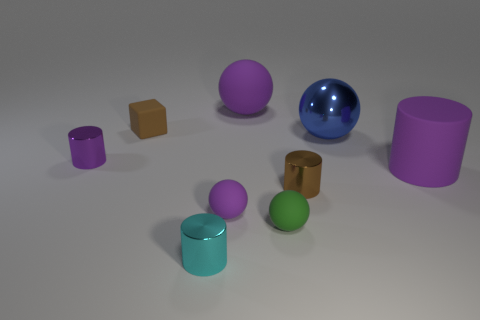There is a metal object that is the same color as the big matte cylinder; what shape is it?
Keep it short and to the point. Cylinder. How many large matte things are there?
Your answer should be very brief. 2. How many big rubber cubes have the same color as the tiny cube?
Provide a succinct answer. 0. There is a small brown thing in front of the rubber cube; does it have the same shape as the large rubber thing that is right of the tiny green sphere?
Provide a succinct answer. Yes. There is a matte thing to the right of the tiny cylinder to the right of the tiny metallic cylinder that is in front of the small brown metallic cylinder; what color is it?
Offer a terse response. Purple. The big sphere that is to the left of the blue thing is what color?
Offer a very short reply. Purple. What color is the shiny thing that is the same size as the purple rubber cylinder?
Give a very brief answer. Blue. Is the purple metal thing the same size as the brown cylinder?
Offer a very short reply. Yes. How many large spheres are behind the metal sphere?
Provide a short and direct response. 1. How many things are either small purple metallic cylinders that are to the left of the cyan metallic object or brown metal cylinders?
Your answer should be compact. 2. 